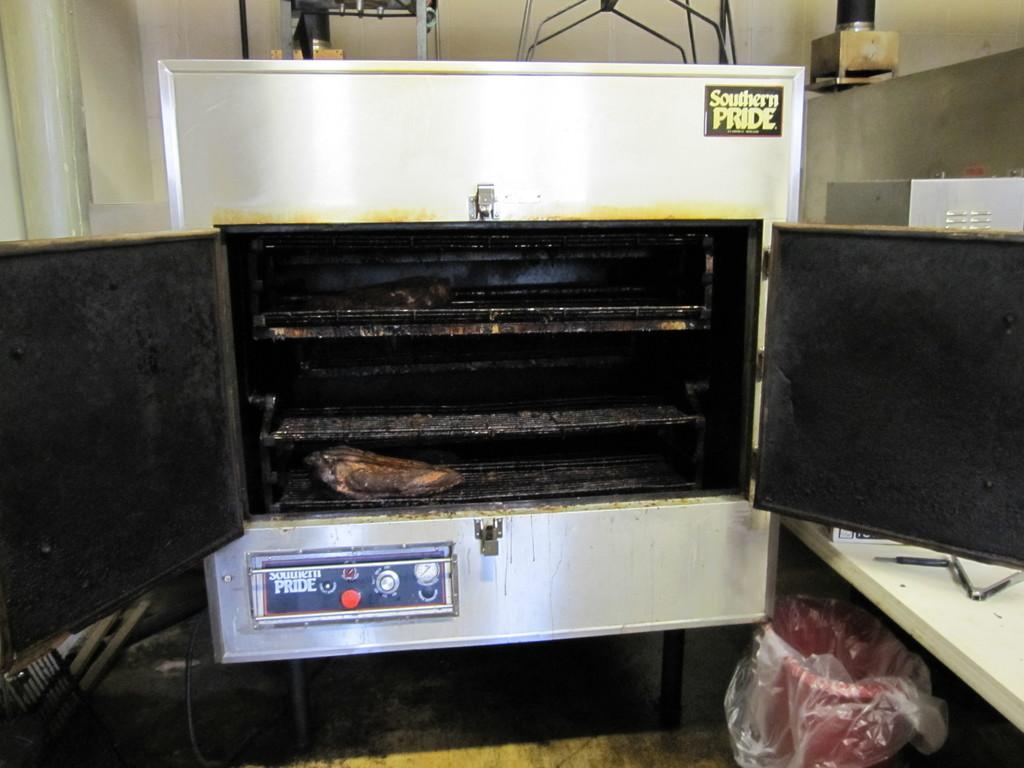<image>
Create a compact narrative representing the image presented. A southern pride smoker grill has its doors opened and a smoked meat on the bottom shelf is seen. 